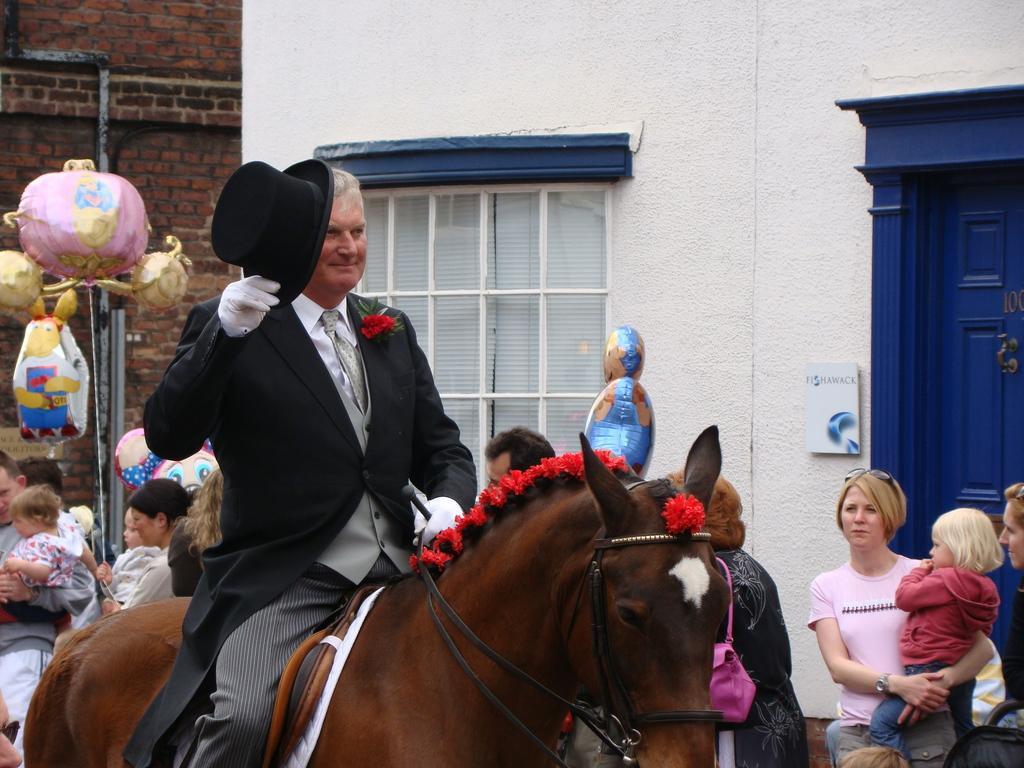Please provide a concise description of this image. In this image I can see a man wearing black jacket, white shirt and sitting on a horse. In the background I can see some of the people are standing. On the right bottom of the side a lady is carrying a baby. Behind her there is a door. In the background I can see two buildings. On the left side there are some toys. The man who is sitting on is holding cap in his right hand. 